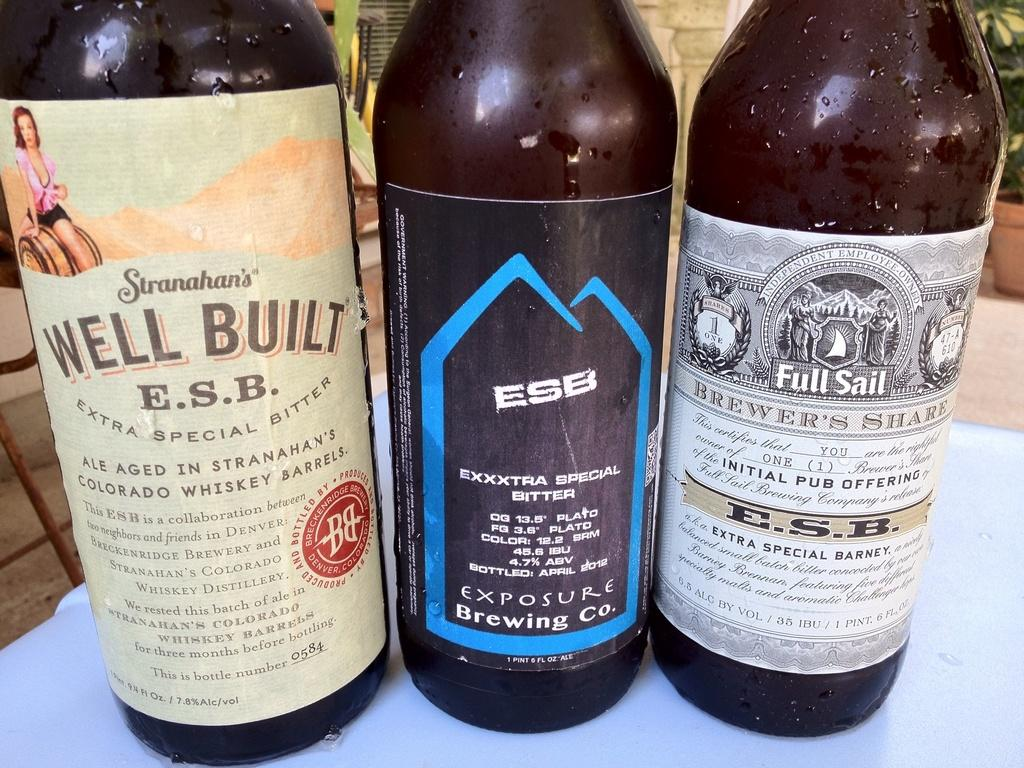<image>
Relay a brief, clear account of the picture shown. A bottle of Well Built E.S.B next to two other bottles of alcohol. 